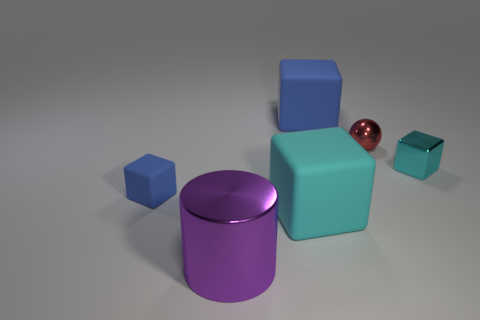How big is the shiny object to the left of the big blue cube?
Your answer should be compact. Large. Are there more purple metal things left of the tiny cyan object than big cyan metallic balls?
Give a very brief answer. Yes. There is a large shiny object; what shape is it?
Offer a terse response. Cylinder. There is a cube that is to the right of the red object; does it have the same color as the big block behind the small cyan shiny block?
Offer a very short reply. No. Is the shape of the large cyan rubber object the same as the cyan shiny object?
Make the answer very short. Yes. Is there anything else that is the same shape as the large shiny thing?
Ensure brevity in your answer.  No. Is the tiny thing left of the large purple cylinder made of the same material as the big cylinder?
Make the answer very short. No. The thing that is both behind the small cyan metal object and left of the small ball has what shape?
Offer a very short reply. Cube. Is there a small metal sphere behind the tiny thing that is on the left side of the big cylinder?
Your answer should be compact. Yes. What number of other objects are the same material as the tiny ball?
Give a very brief answer. 2. 